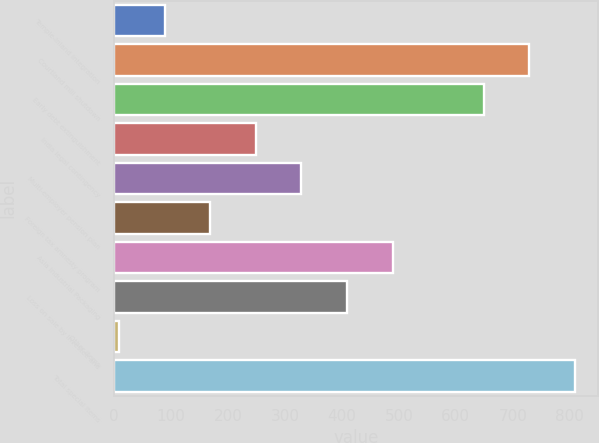Convert chart to OTSL. <chart><loc_0><loc_0><loc_500><loc_500><bar_chart><fcel>Temple-Inland integration<fcel>Courtland mill shutdown<fcel>Early debt extinguishment<fcel>India legal contingency<fcel>Multi-employer pension plan<fcel>Foreign tax amnesty program<fcel>Asia Industrial Packaging<fcel>Loss on sale by investee and<fcel>Other items<fcel>Total special items<nl><fcel>89<fcel>729<fcel>649<fcel>249<fcel>329<fcel>169<fcel>489<fcel>409<fcel>9<fcel>809<nl></chart> 